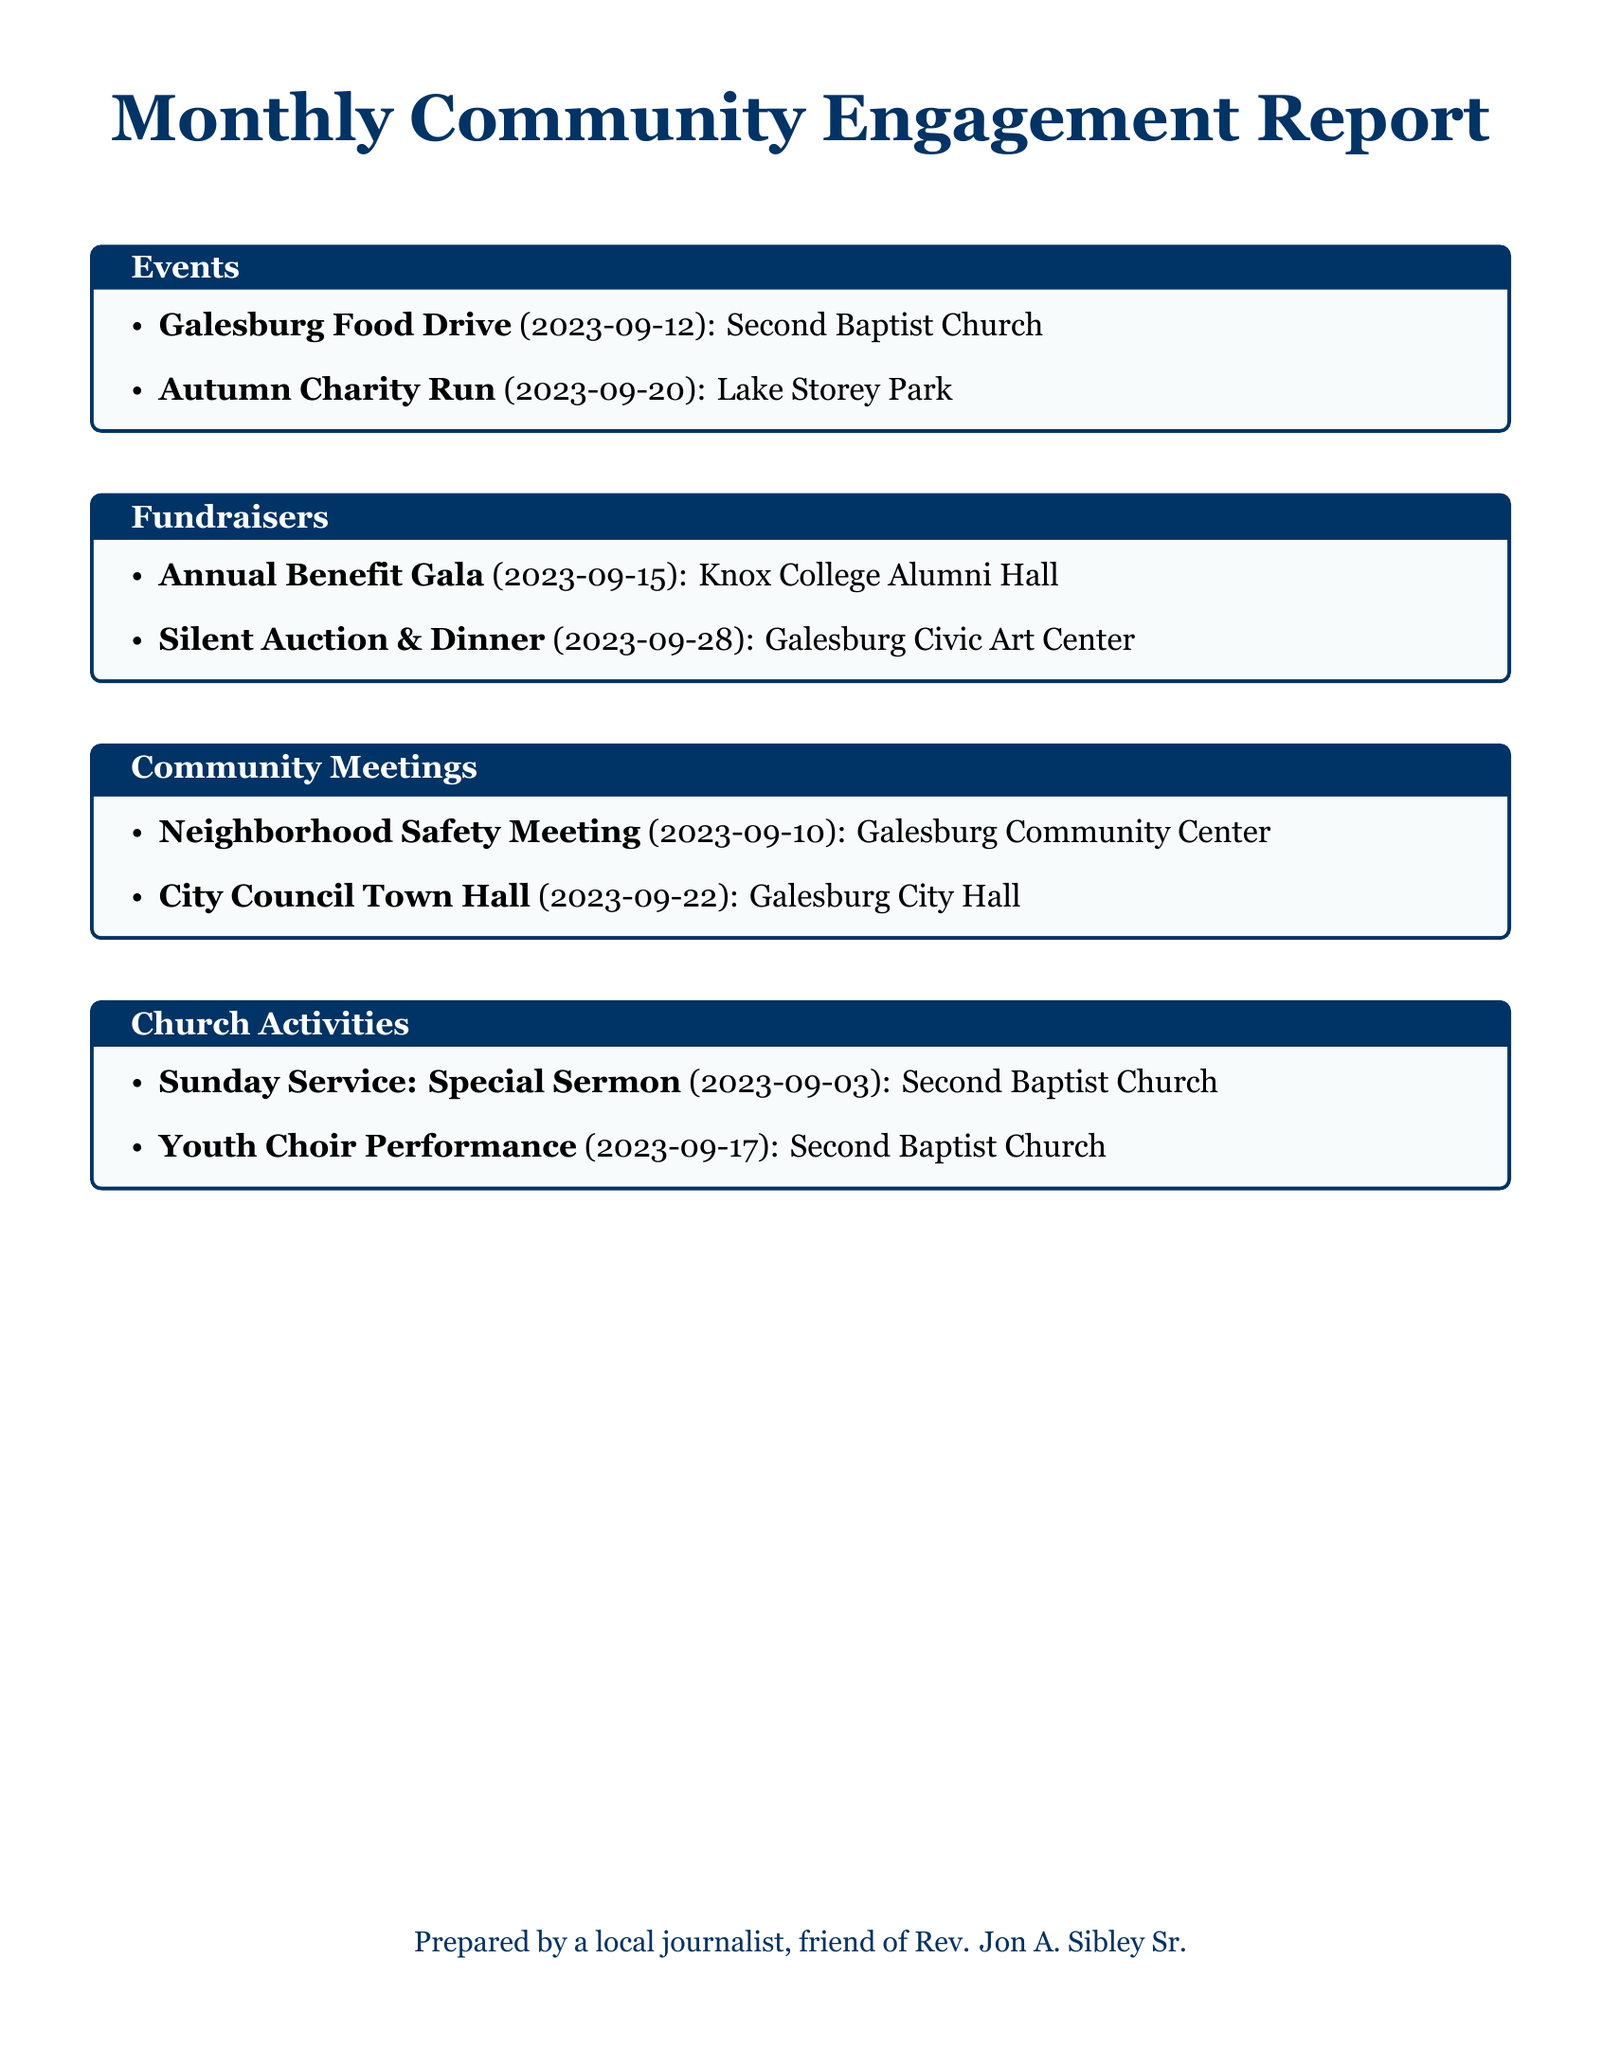What was the date of the Galesburg Food Drive? The date for the Galesburg Food Drive is specified in the document as September 12, 2023.
Answer: September 12, 2023 How many fundraisers are listed in the report? There are two fundraisers mentioned in the document: the Annual Benefit Gala and the Silent Auction & Dinner.
Answer: 2 Where was the Autumn Charity Run held? The location for the Autumn Charity Run is provided in the document as Lake Storey Park.
Answer: Lake Storey Park What type of meeting is held on September 22, 2023? The document states that a City Council Town Hall is scheduled for that date, indicating the meeting type.
Answer: City Council Town Hall Which church held the Youth Choir Performance? The document indicates that the Youth Choir Performance was held at Second Baptist Church.
Answer: Second Baptist Church What are the two types of events organized by Rev. Jon A. Sibley Sr. mentioned in the report? The document mentions events like Food Drives and Charity Runs as part of community engagement activities organized by Rev. Jon A. Sibley Sr.
Answer: Food Drives and Charity Runs What is the title of the special sermon held on September 3? According to the document, the event is labeled as a Sunday Service: Special Sermon, referencing the title.
Answer: Sunday Service: Special Sermon What is the purpose of the Neighborhood Safety Meeting? The purpose inferred from the title in the document is community discussion and safety concerns.
Answer: Community discussion and safety concerns 